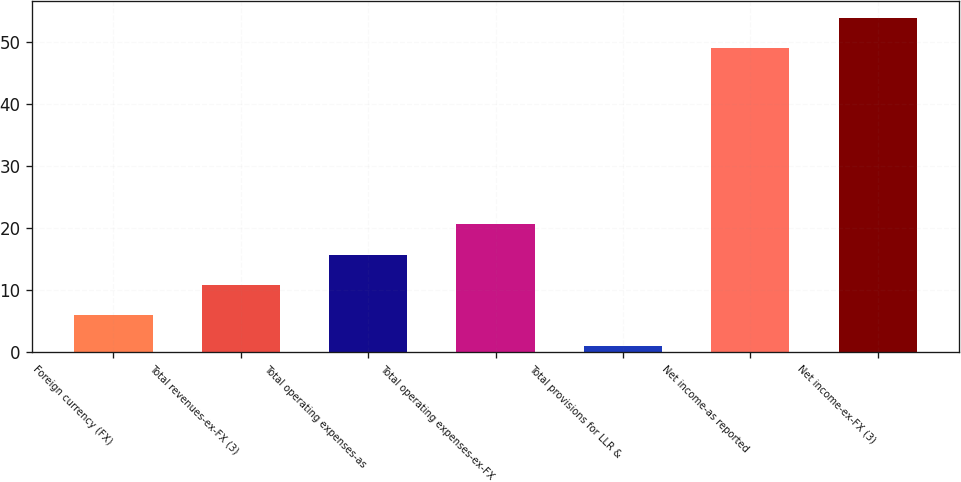<chart> <loc_0><loc_0><loc_500><loc_500><bar_chart><fcel>Foreign currency (FX)<fcel>Total revenues-ex-FX (3)<fcel>Total operating expenses-as<fcel>Total operating expenses-ex-FX<fcel>Total provisions for LLR &<fcel>Net income-as reported<fcel>Net income-ex-FX (3)<nl><fcel>5.9<fcel>10.8<fcel>15.7<fcel>20.6<fcel>1<fcel>49<fcel>53.9<nl></chart> 